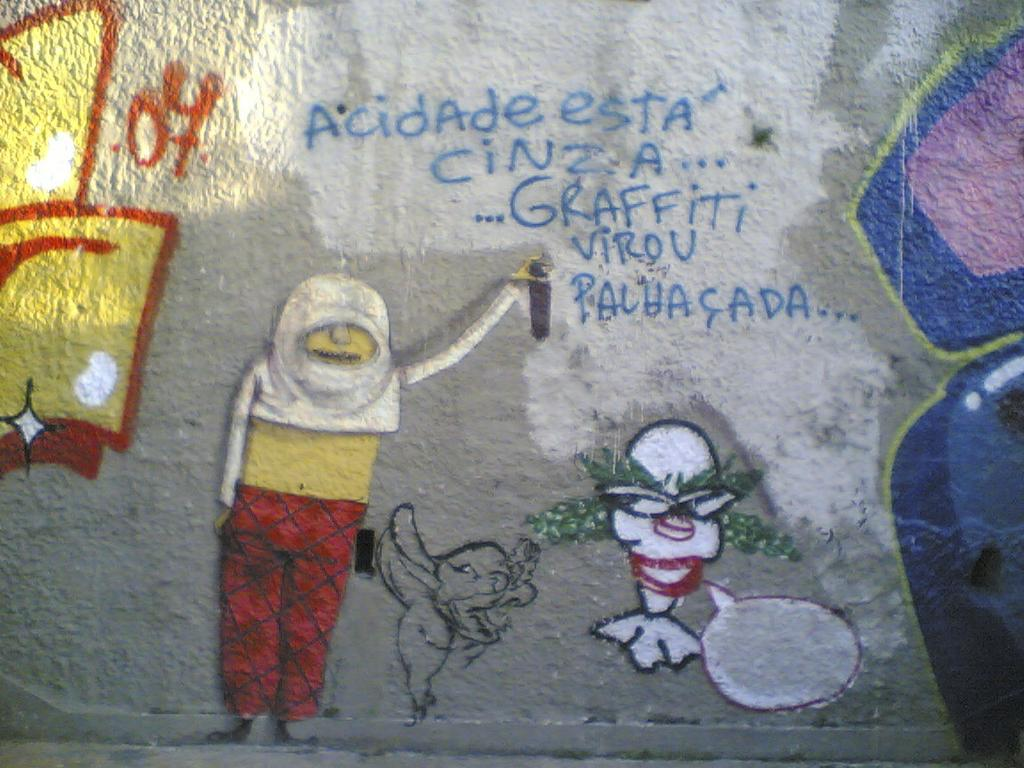What is depicted on the wall in the foreground of the image? There are graffiti paintings on the wall in the foreground of the image. What can be found on the graffiti paintings? There is text on the graffiti paintings. What is the reason for the building's attraction in the image? There is no building present in the image, only graffiti paintings on a wall. 